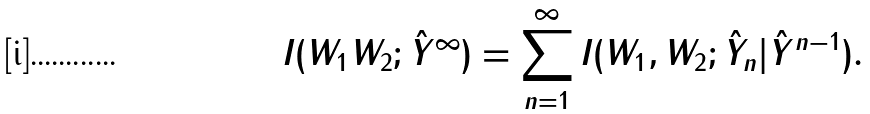Convert formula to latex. <formula><loc_0><loc_0><loc_500><loc_500>I ( W _ { 1 } W _ { 2 } ; \hat { Y } ^ { \infty } ) & = \sum _ { n = 1 } ^ { \infty } I ( W _ { 1 } , W _ { 2 } ; \hat { Y } _ { n } | \hat { Y } ^ { n - 1 } ) .</formula> 